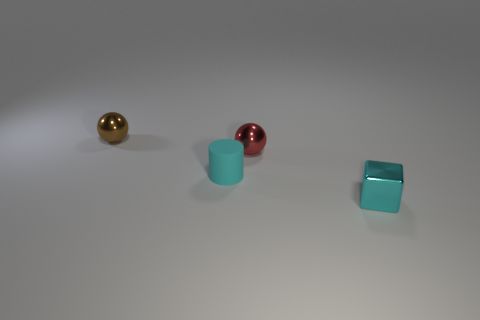There is a matte cylinder; does it have the same color as the small shiny thing in front of the tiny cyan matte thing?
Your response must be concise. Yes. There is a ball that is right of the brown metal object; what number of small cylinders are to the right of it?
Provide a succinct answer. 0. Is there anything else that is the same material as the tiny cylinder?
Keep it short and to the point. No. What material is the small cyan object behind the shiny cube in front of the small metallic ball that is to the right of the tiny brown ball?
Your response must be concise. Rubber. What is the material of the small thing that is right of the brown object and behind the matte object?
Offer a terse response. Metal. How many other tiny things have the same shape as the brown object?
Your answer should be compact. 1. Do the object to the right of the red sphere and the tiny matte cylinder on the left side of the tiny red ball have the same color?
Your answer should be very brief. Yes. What number of balls are behind the small sphere that is behind the small ball that is in front of the small brown sphere?
Your answer should be compact. 0. How many small things are behind the small rubber thing and to the right of the tiny brown ball?
Your answer should be compact. 1. Are there more blocks that are right of the tiny cyan rubber cylinder than small yellow cylinders?
Your answer should be compact. Yes. 